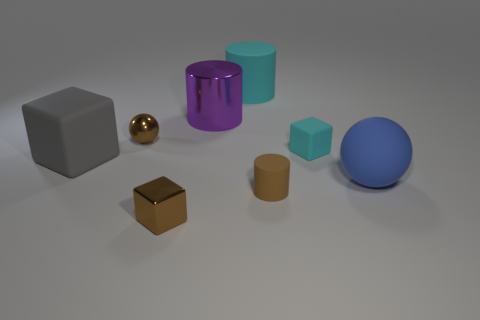Add 1 large yellow shiny cubes. How many objects exist? 9 Subtract all spheres. How many objects are left? 6 Add 4 brown shiny things. How many brown shiny things exist? 6 Subtract 0 red cylinders. How many objects are left? 8 Subtract all large purple metallic cylinders. Subtract all cyan things. How many objects are left? 5 Add 2 brown metal cubes. How many brown metal cubes are left? 3 